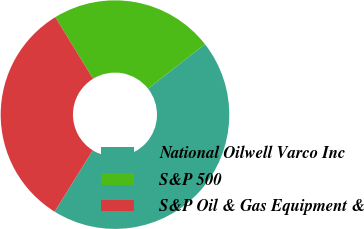Convert chart to OTSL. <chart><loc_0><loc_0><loc_500><loc_500><pie_chart><fcel>National Oilwell Varco Inc<fcel>S&P 500<fcel>S&P Oil & Gas Equipment &<nl><fcel>44.43%<fcel>23.16%<fcel>32.4%<nl></chart> 